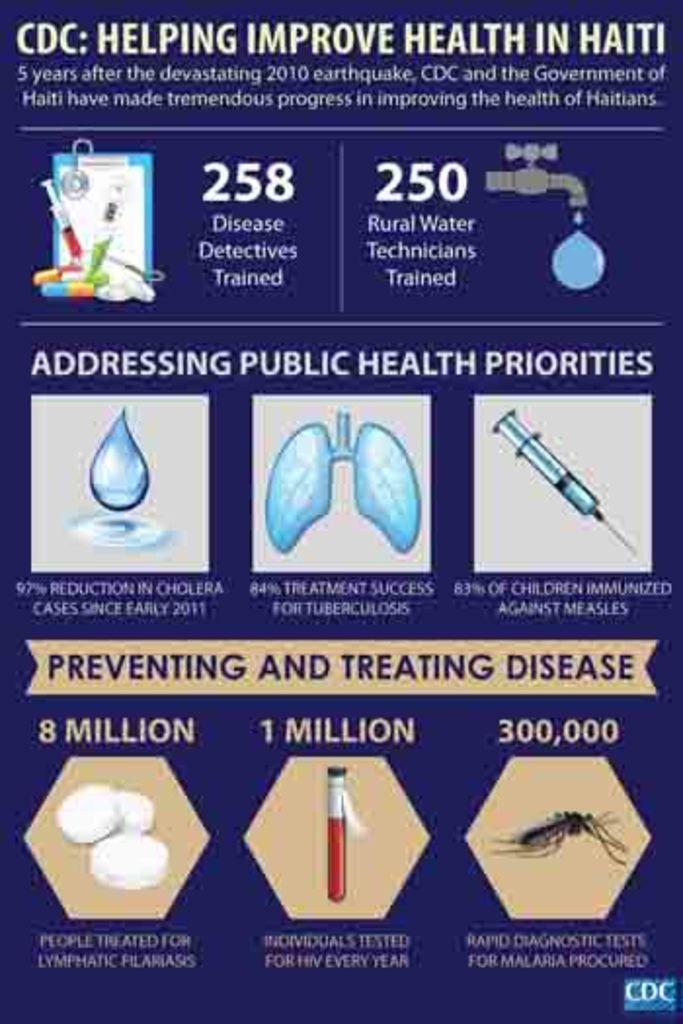Can you describe this image briefly? In this picture we can see the poster. In the poster we can see the injection, depiction of a kidney, water drop, mosquito, capsule and other objects. At the top we can see the quotation. 